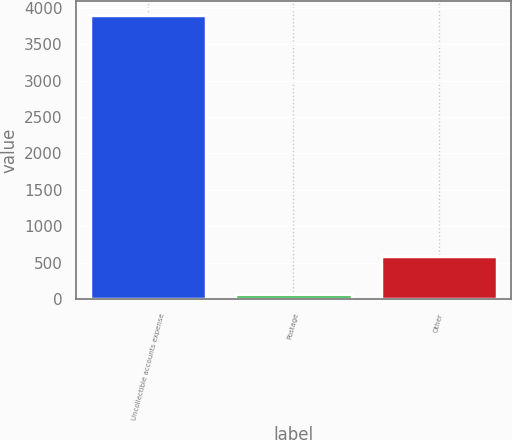Convert chart. <chart><loc_0><loc_0><loc_500><loc_500><bar_chart><fcel>Uncollectible accounts expense<fcel>Postage<fcel>Other<nl><fcel>3902<fcel>63<fcel>597<nl></chart> 